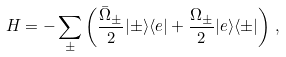Convert formula to latex. <formula><loc_0><loc_0><loc_500><loc_500>H = - \sum _ { \pm } \left ( \frac { \bar { \Omega } _ { \pm } } { 2 } | \pm \rangle \langle e | + \frac { \Omega _ { \pm } } { 2 } | e \rangle \langle \pm | \right ) \, ,</formula> 